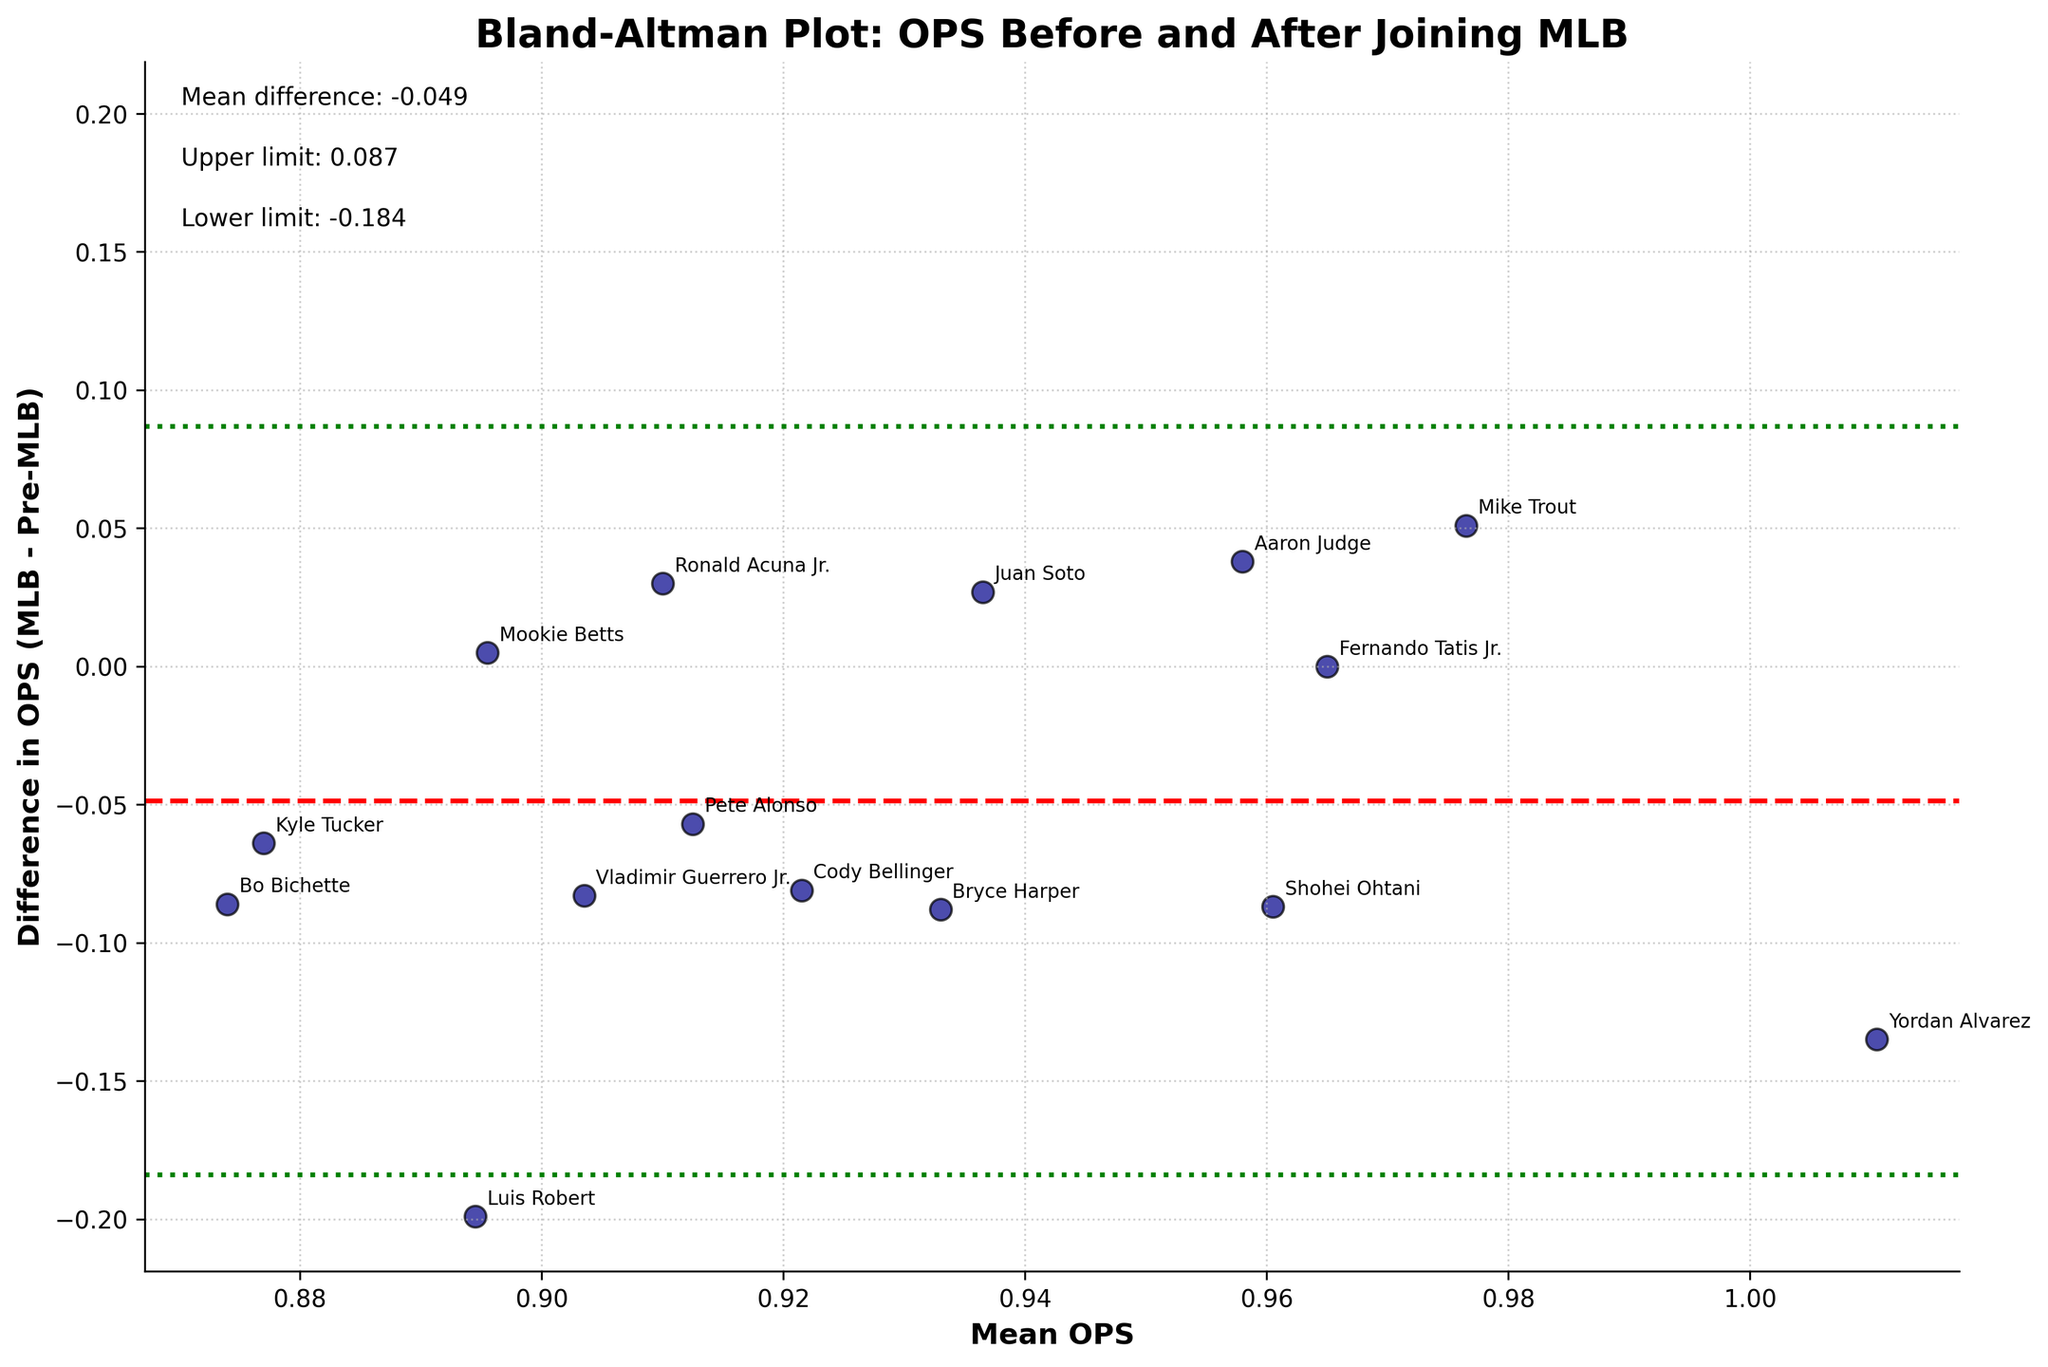What is the title of the plot? The title of the plot is typically found at the top of the figure. In this case, it clearly states "Bland-Altman Plot: OPS Before and After Joining MLB".
Answer: Bland-Altman Plot: OPS Before and After Joining MLB How many athletes showed a decrease in their OPS after joining the MLB? By observing the points below the zero-difference line, we can count the number of athletes who have a negative difference in OPS. There are Bryce Harper, Cody Bellinger, Pete Alonso, Yordan Alvarez, Vladimir Guerrero Jr., Bo Bichette, Shohei Ohtani, Luis Robert, and Kyle Tucker.
Answer: 9 Which athlete had the largest negative difference in OPS after joining the MLB? We identify the point with the lowest value on the y-axis. The labels help us see that Luis Robert had the largest negative difference in OPS after joining MLB.
Answer: Luis Robert What is the mean difference in OPS before and after joining the MLB? The mean difference is indicated by a dashed red line on the plot, and there is a text annotation that states, "Mean difference: -0.045".
Answer: -0.045 What are the upper and lower limits of agreement in this plot? The upper and lower limits of agreement are shown as dotted green lines and are also annotated in the text as "Upper limit: 0.247" and "Lower limit: -0.337".
Answer: Upper limit: 0.247, Lower limit: -0.337 Which athlete had the closest OPS value between pre-MLB and MLB? The athlete with a difference closest to zero will be on the point lying nearest to the horizontal zero-difference line. This is Fernando Tatis Jr.
Answer: Fernando Tatis Jr How many athletes had an increase in their OPS after joining the MLB? By counting the points above the zero-difference line, we find the athletes with a positive difference in OPS. There are Mike Trout, Aaron Judge, Mookie Betts, Ronald Acuna Jr., Juan Soto.
Answer: 5 What are the x-axis and y-axis labels in the plot? By looking at the bottom and the side of the plot, we see the x-axis label is "Mean OPS" and the y-axis label is "Difference in OPS (MLB - Pre-MLB)".
Answer: X-axis: Mean OPS, Y-axis: Difference in OPS (MLB - Pre-MLB) Which two athletes had a similar mean OPS, but had very different differences in OPS before and after joining the MLB? By identifying two points that are horizontally close but vertically distant, we notice that Yordan Alvarez and Cody Bellinger have similar mean OPS values but their differences in OPS are quite distinct.
Answer: Yordan Alvarez and Cody Bellinger What is the standard deviation of the differences in OPS? The standard deviation is not directly labeled on the plot, but we can use the information that the limits of agreement are calculated using mean ± 1.96*standard deviation. Given the upper limit (0.247) and the mean difference (-0.045), we solve for the standard deviation as follows: upper limit = -0.045 + 1.96*std_dev, therefore, std_dev = (0.247 + 0.045) / 1.96.
Answer: 0.149 